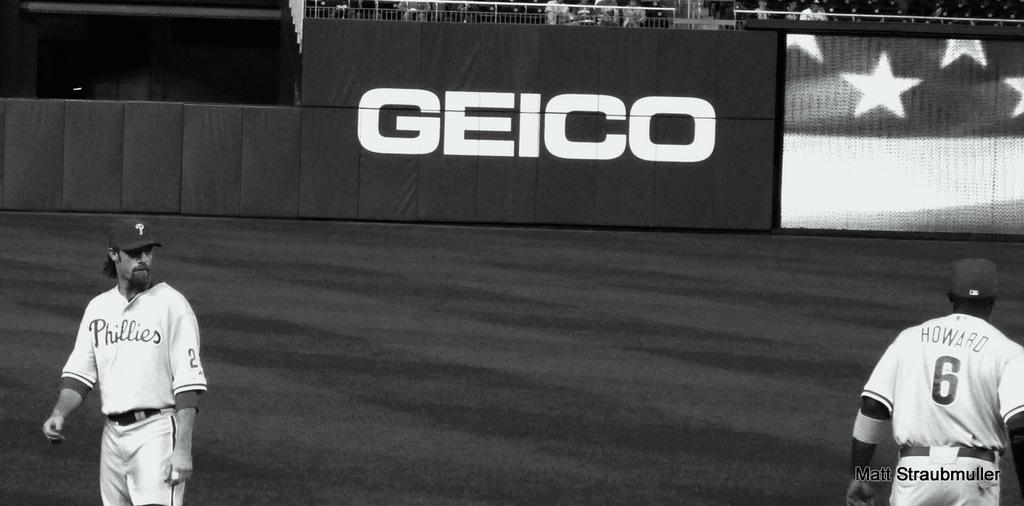<image>
Present a compact description of the photo's key features. baseball players on the field in front of a Geico banner 